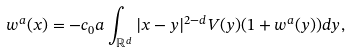Convert formula to latex. <formula><loc_0><loc_0><loc_500><loc_500>w ^ { a } ( x ) = - c _ { 0 } a \int _ { \mathbb { R } ^ { d } } | x - y | ^ { 2 - d } V ( y ) ( 1 + w ^ { a } ( y ) ) d y ,</formula> 